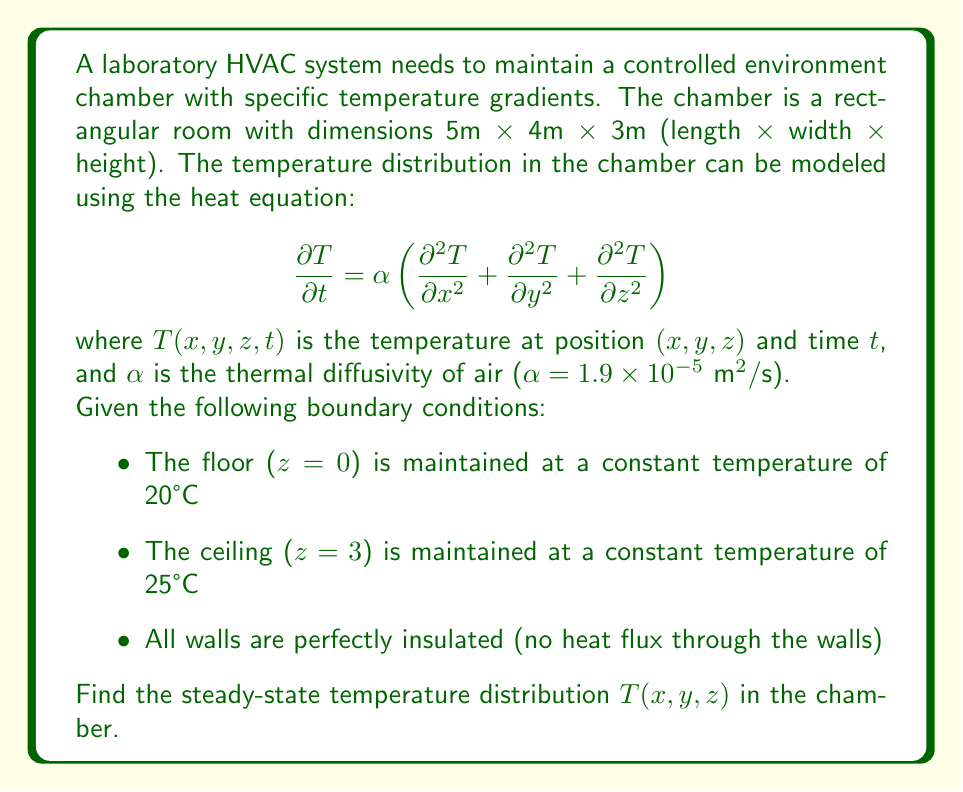Could you help me with this problem? To solve this problem, we need to follow these steps:

1) For steady-state conditions, the temperature doesn't change with time, so $\frac{\partial T}{\partial t} = 0$. The heat equation reduces to:

   $$0 = \frac{\partial^2 T}{\partial x^2} + \frac{\partial^2 T}{\partial y^2} + \frac{\partial^2 T}{\partial z^2}$$

2) Given the boundary conditions, we can see that the temperature only varies in the z-direction. Therefore:

   $$\frac{\partial^2 T}{\partial x^2} = \frac{\partial^2 T}{\partial y^2} = 0$$

3) Our equation simplifies to:

   $$\frac{d^2 T}{dz^2} = 0$$

4) Integrating twice:

   $$\frac{dT}{dz} = C_1$$
   $$T(z) = C_1z + C_2$$

5) Now we apply the boundary conditions:
   
   At z = 0, T = 20°C
   At z = 3m, T = 25°C

6) Substituting these into our equation:

   20 = C_2
   25 = 3C_1 + C_2

7) Solving these equations:

   C_2 = 20
   C_1 = 5/3

8) Therefore, our final temperature distribution is:

   $$T(z) = \frac{5}{3}z + 20$$

This represents a linear temperature gradient from 20°C at the floor to 25°C at the ceiling.
Answer: The steady-state temperature distribution in the chamber is given by:

$$T(z) = \frac{5}{3}z + 20$$

where $z$ is the height in meters from the floor, and $T$ is in degrees Celsius. 